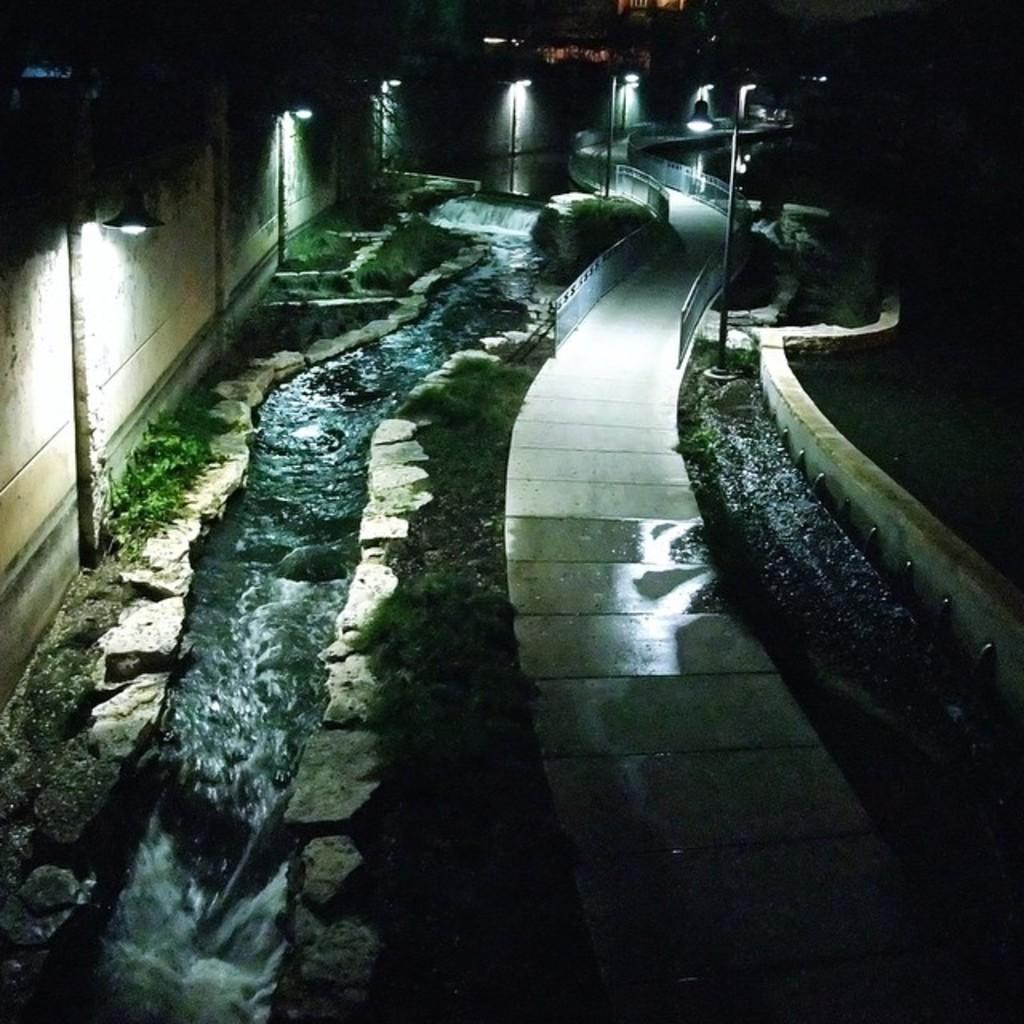Describe this image in one or two sentences. At the bottom of the picture, we see the pavement. Beside that, we see the grass. Beside that, we see the water is flowing. On the left side, we see a wall, poles and lights. In the background, we see the streetlights and the road railing. In the background, it is black in color. This picture is clicked in the dark. 